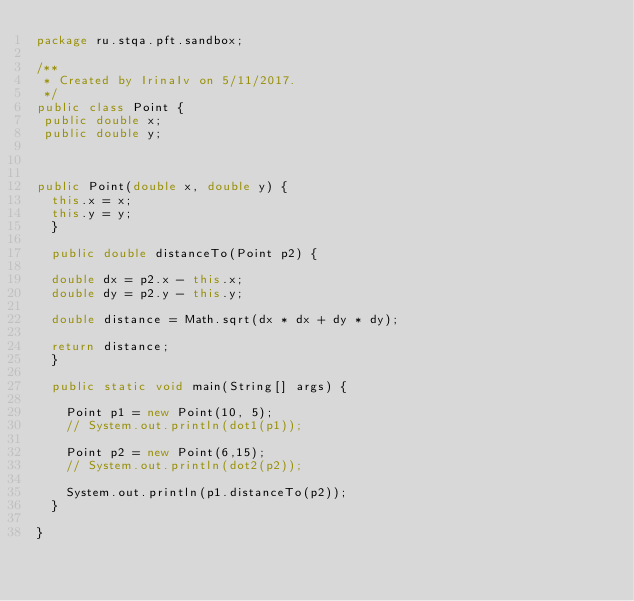<code> <loc_0><loc_0><loc_500><loc_500><_Java_>package ru.stqa.pft.sandbox;

/**
 * Created by IrinaIv on 5/11/2017.
 */
public class Point {
 public double x;
 public double y;



public Point(double x, double y) {
  this.x = x;
  this.y = y;
  }

  public double distanceTo(Point p2) {

  double dx = p2.x - this.x;
  double dy = p2.y - this.y;

  double distance = Math.sqrt(dx * dx + dy * dy);

  return distance;
  }

  public static void main(String[] args) {

    Point p1 = new Point(10, 5);
    // System.out.println(dot1(p1));

    Point p2 = new Point(6,15);
    // System.out.println(dot2(p2));

    System.out.println(p1.distanceTo(p2));
  }

}
</code> 